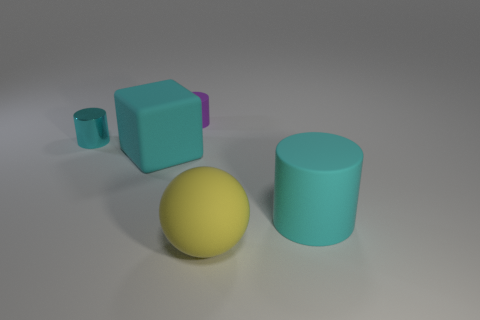Add 3 large cyan rubber blocks. How many objects exist? 8 Subtract all cylinders. How many objects are left? 2 Subtract 0 yellow cylinders. How many objects are left? 5 Subtract all tiny green matte cylinders. Subtract all big rubber cubes. How many objects are left? 4 Add 1 large matte things. How many large matte things are left? 4 Add 3 large cyan shiny spheres. How many large cyan shiny spheres exist? 3 